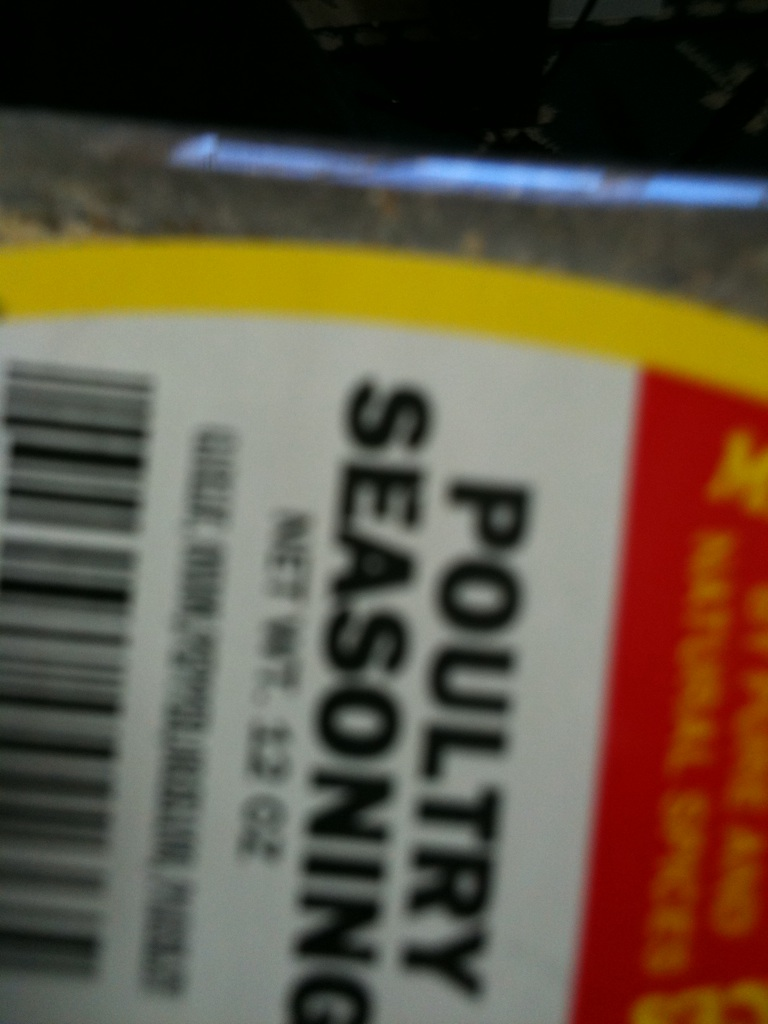Could you suggest a recipe using poultry seasoning? Certainly! A simple recipe to try is a classic roasted chicken. Start by preheating your oven to 375 degrees Fahrenheit. Rub the chicken inside and out with poultry seasoning, adding salt and pepper to taste. Place the chicken in a roasting pan and cook it until the internal temperature reaches 165 degrees Fahrenheit. Let it rest before carving, and you'll have a perfectly seasoned meal. 